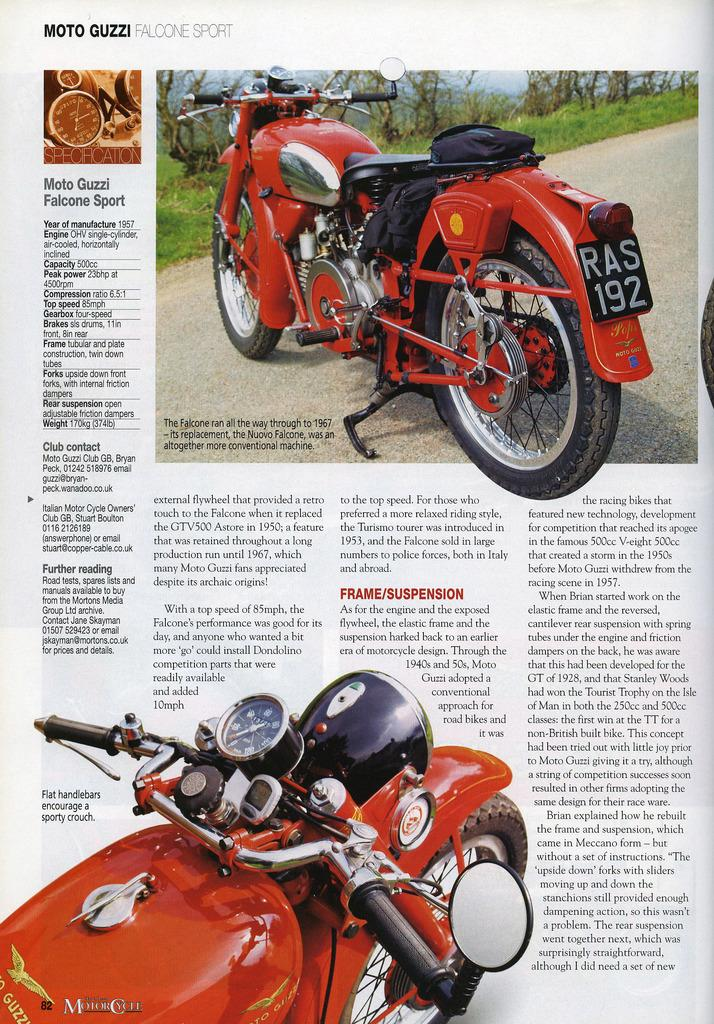How many bikes are in the image? There are two bikes in the image. What are the colors of the bikes? One bike is red, and the other is black. What features do the bikes have? The bikes have number plates and mirrors. Is there any text on the bikes? Yes, there is writing on the bikes. What can be seen in the background of the image? There are trees and green grass in the background of the image. What type of letters can be seen being delivered in the scene? There is no scene of letters being delivered in the image; it only features two bikes with number plates, mirrors, and writing. How much pain is the red bike experiencing in the image? Bikes do not experience pain, so this question cannot be answered. 